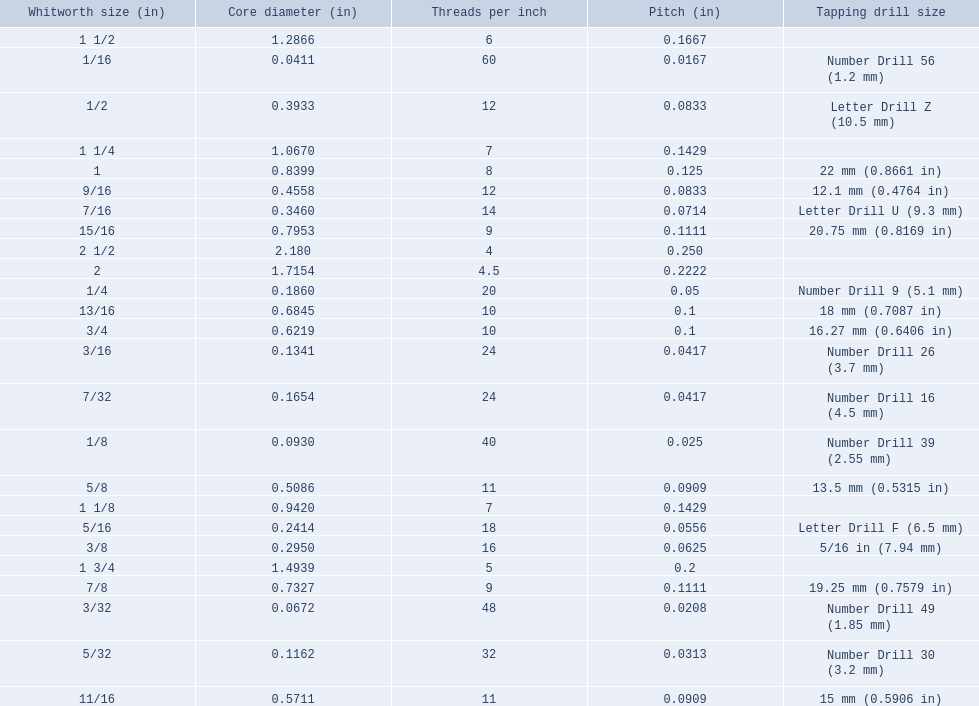What was the core diameter of a number drill 26 0.1341. What is this measurement in whitworth size? 3/16. 